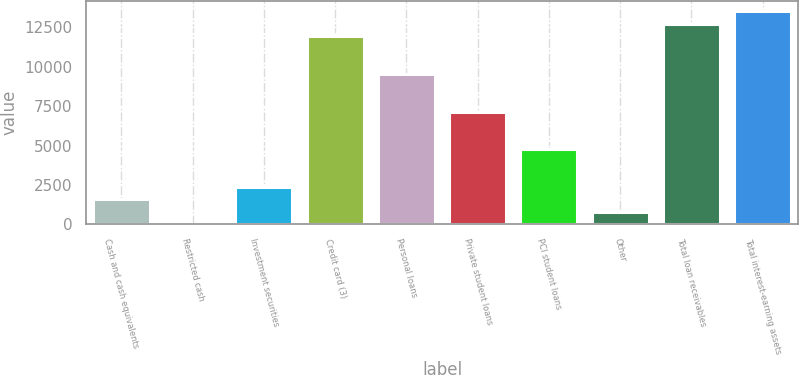Convert chart. <chart><loc_0><loc_0><loc_500><loc_500><bar_chart><fcel>Cash and cash equivalents<fcel>Restricted cash<fcel>Investment securities<fcel>Credit card (3)<fcel>Personal loans<fcel>Private student loans<fcel>PCI student loans<fcel>Other<fcel>Total loan receivables<fcel>Total interest-earning assets<nl><fcel>1589.8<fcel>1<fcel>2384.2<fcel>11917<fcel>9533.8<fcel>7150.6<fcel>4767.4<fcel>795.4<fcel>12711.4<fcel>13505.8<nl></chart> 